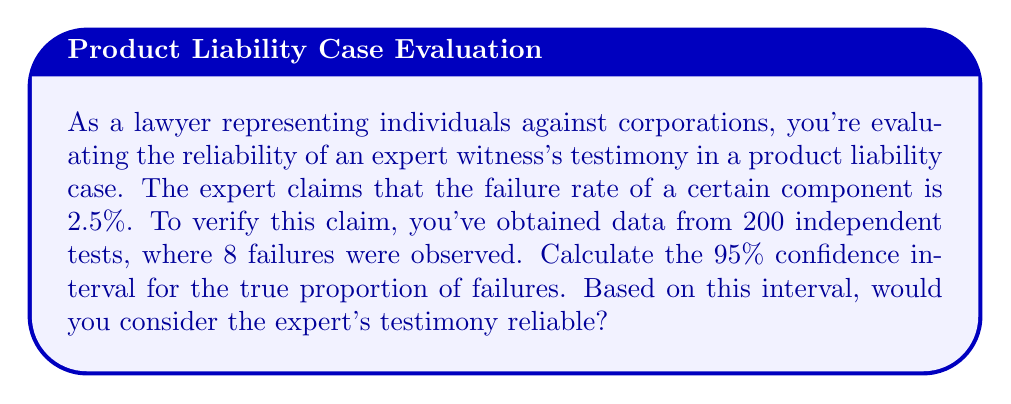Can you answer this question? Let's approach this step-by-step:

1) We're dealing with a proportion, so we'll use the formula for the confidence interval of a proportion:

   $$p \pm z\sqrt{\frac{p(1-p)}{n}}$$

   where $p$ is the sample proportion, $n$ is the sample size, and $z$ is the z-score for the desired confidence level.

2) Calculate the sample proportion:
   $p = \frac{8}{200} = 0.04$ or 4%

3) For a 95% confidence interval, the z-score is 1.96.

4) Now, let's plug these values into our formula:

   $$0.04 \pm 1.96\sqrt{\frac{0.04(1-0.04)}{200}}$$

5) Simplify:
   $$0.04 \pm 1.96\sqrt{\frac{0.0384}{200}} = 0.04 \pm 1.96(0.0138)$$

6) Calculate the margin of error:
   $$1.96(0.0138) = 0.027$$

7) Therefore, the confidence interval is:
   $$0.04 \pm 0.027$$
   or (0.013, 0.067)

8) Convert to percentages:
   (1.3%, 6.7%)

9) Interpret: We can be 95% confident that the true proportion of failures falls between 1.3% and 6.7%.

10) The expert's claim of 2.5% falls within this interval, suggesting that their testimony is consistent with the observed data and could be considered reliable.
Answer: 95% CI: (1.3%, 6.7%). Expert's claim (2.5%) falls within the interval, suggesting reliability. 